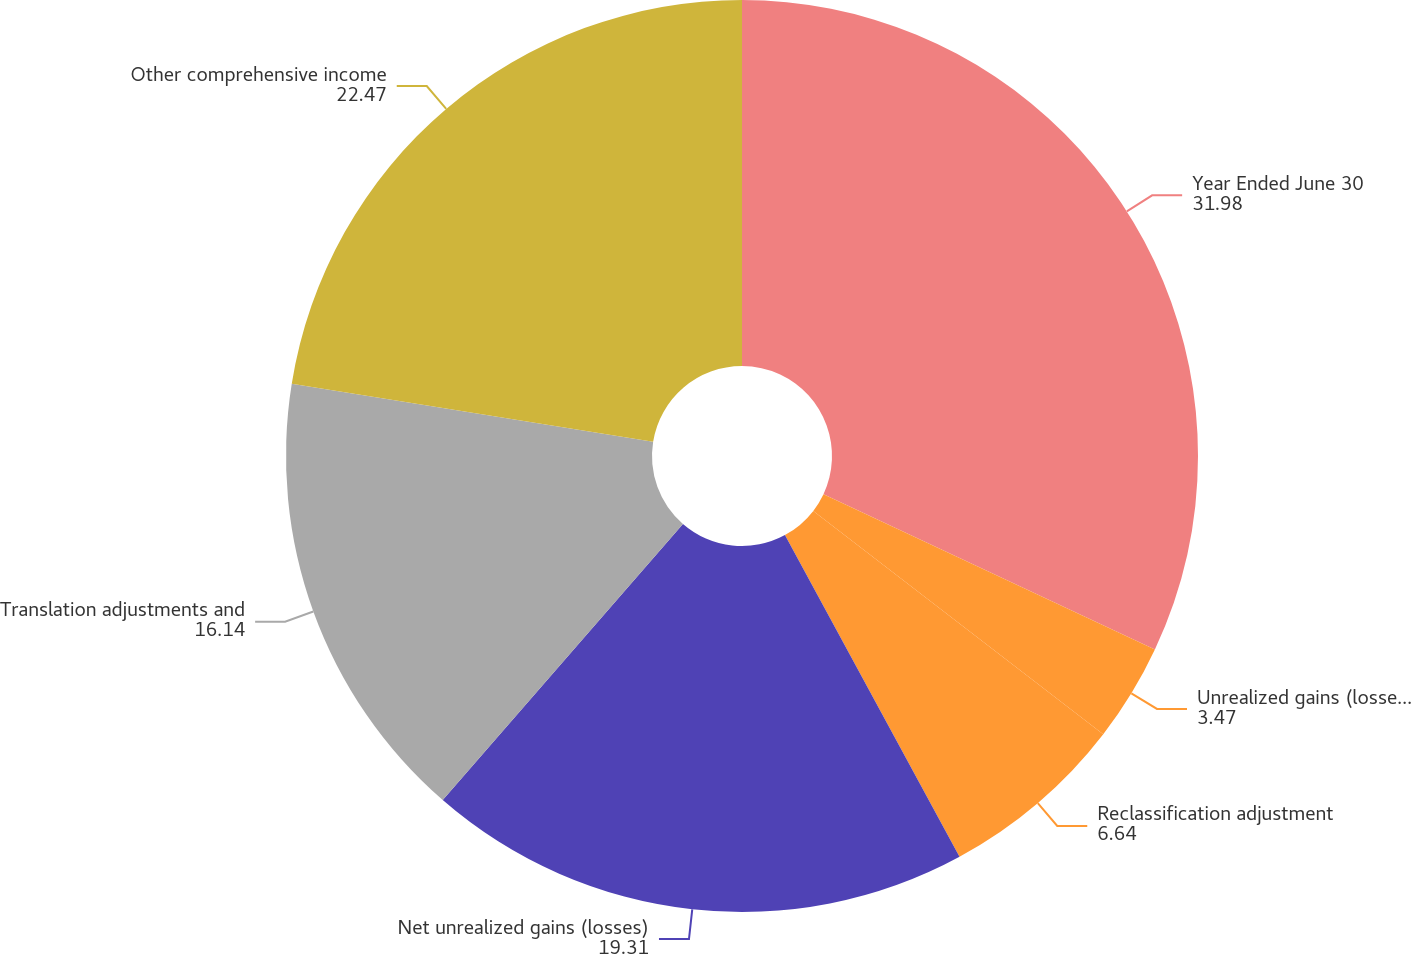Convert chart. <chart><loc_0><loc_0><loc_500><loc_500><pie_chart><fcel>Year Ended June 30<fcel>Unrealized gains (losses) net<fcel>Reclassification adjustment<fcel>Net unrealized gains (losses)<fcel>Translation adjustments and<fcel>Other comprehensive income<nl><fcel>31.98%<fcel>3.47%<fcel>6.64%<fcel>19.31%<fcel>16.14%<fcel>22.47%<nl></chart> 